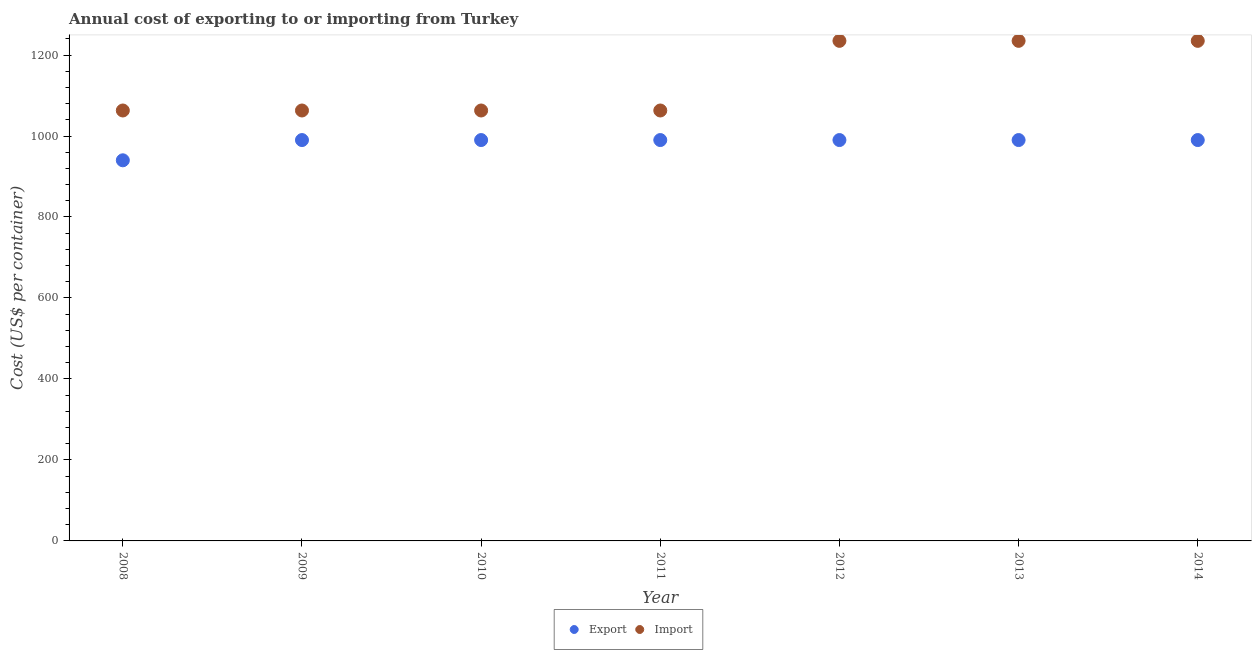How many different coloured dotlines are there?
Give a very brief answer. 2. What is the export cost in 2008?
Offer a terse response. 940. Across all years, what is the maximum export cost?
Provide a succinct answer. 990. Across all years, what is the minimum import cost?
Give a very brief answer. 1063. In which year was the export cost maximum?
Your response must be concise. 2009. In which year was the import cost minimum?
Ensure brevity in your answer.  2008. What is the total import cost in the graph?
Your answer should be compact. 7957. What is the difference between the export cost in 2008 and that in 2014?
Provide a succinct answer. -50. What is the difference between the export cost in 2011 and the import cost in 2012?
Your answer should be compact. -245. What is the average import cost per year?
Your answer should be very brief. 1136.71. In the year 2013, what is the difference between the import cost and export cost?
Provide a short and direct response. 245. What is the ratio of the import cost in 2009 to that in 2014?
Your answer should be very brief. 0.86. Is the import cost in 2013 less than that in 2014?
Your response must be concise. No. Is the difference between the import cost in 2008 and 2009 greater than the difference between the export cost in 2008 and 2009?
Keep it short and to the point. Yes. What is the difference between the highest and the second highest export cost?
Provide a succinct answer. 0. What is the difference between the highest and the lowest import cost?
Make the answer very short. 172. Is the sum of the import cost in 2010 and 2014 greater than the maximum export cost across all years?
Offer a very short reply. Yes. What is the difference between two consecutive major ticks on the Y-axis?
Offer a very short reply. 200. Does the graph contain any zero values?
Make the answer very short. No. How are the legend labels stacked?
Provide a short and direct response. Horizontal. What is the title of the graph?
Keep it short and to the point. Annual cost of exporting to or importing from Turkey. Does "Health Care" appear as one of the legend labels in the graph?
Your answer should be very brief. No. What is the label or title of the Y-axis?
Give a very brief answer. Cost (US$ per container). What is the Cost (US$ per container) in Export in 2008?
Give a very brief answer. 940. What is the Cost (US$ per container) of Import in 2008?
Give a very brief answer. 1063. What is the Cost (US$ per container) of Export in 2009?
Keep it short and to the point. 990. What is the Cost (US$ per container) in Import in 2009?
Offer a very short reply. 1063. What is the Cost (US$ per container) in Export in 2010?
Your response must be concise. 990. What is the Cost (US$ per container) in Import in 2010?
Ensure brevity in your answer.  1063. What is the Cost (US$ per container) of Export in 2011?
Your answer should be compact. 990. What is the Cost (US$ per container) of Import in 2011?
Ensure brevity in your answer.  1063. What is the Cost (US$ per container) of Export in 2012?
Give a very brief answer. 990. What is the Cost (US$ per container) of Import in 2012?
Provide a succinct answer. 1235. What is the Cost (US$ per container) of Export in 2013?
Offer a very short reply. 990. What is the Cost (US$ per container) of Import in 2013?
Offer a very short reply. 1235. What is the Cost (US$ per container) in Export in 2014?
Give a very brief answer. 990. What is the Cost (US$ per container) of Import in 2014?
Give a very brief answer. 1235. Across all years, what is the maximum Cost (US$ per container) in Export?
Your answer should be very brief. 990. Across all years, what is the maximum Cost (US$ per container) of Import?
Your response must be concise. 1235. Across all years, what is the minimum Cost (US$ per container) in Export?
Provide a short and direct response. 940. Across all years, what is the minimum Cost (US$ per container) in Import?
Offer a terse response. 1063. What is the total Cost (US$ per container) of Export in the graph?
Ensure brevity in your answer.  6880. What is the total Cost (US$ per container) of Import in the graph?
Your answer should be very brief. 7957. What is the difference between the Cost (US$ per container) of Export in 2008 and that in 2009?
Keep it short and to the point. -50. What is the difference between the Cost (US$ per container) of Export in 2008 and that in 2011?
Keep it short and to the point. -50. What is the difference between the Cost (US$ per container) in Import in 2008 and that in 2012?
Your response must be concise. -172. What is the difference between the Cost (US$ per container) of Import in 2008 and that in 2013?
Make the answer very short. -172. What is the difference between the Cost (US$ per container) in Export in 2008 and that in 2014?
Provide a short and direct response. -50. What is the difference between the Cost (US$ per container) in Import in 2008 and that in 2014?
Offer a terse response. -172. What is the difference between the Cost (US$ per container) of Import in 2009 and that in 2010?
Provide a short and direct response. 0. What is the difference between the Cost (US$ per container) in Export in 2009 and that in 2011?
Provide a succinct answer. 0. What is the difference between the Cost (US$ per container) in Import in 2009 and that in 2012?
Make the answer very short. -172. What is the difference between the Cost (US$ per container) in Export in 2009 and that in 2013?
Your answer should be very brief. 0. What is the difference between the Cost (US$ per container) of Import in 2009 and that in 2013?
Your answer should be compact. -172. What is the difference between the Cost (US$ per container) in Import in 2009 and that in 2014?
Your response must be concise. -172. What is the difference between the Cost (US$ per container) in Export in 2010 and that in 2012?
Offer a terse response. 0. What is the difference between the Cost (US$ per container) in Import in 2010 and that in 2012?
Provide a succinct answer. -172. What is the difference between the Cost (US$ per container) of Export in 2010 and that in 2013?
Provide a short and direct response. 0. What is the difference between the Cost (US$ per container) of Import in 2010 and that in 2013?
Ensure brevity in your answer.  -172. What is the difference between the Cost (US$ per container) of Import in 2010 and that in 2014?
Keep it short and to the point. -172. What is the difference between the Cost (US$ per container) in Import in 2011 and that in 2012?
Make the answer very short. -172. What is the difference between the Cost (US$ per container) of Import in 2011 and that in 2013?
Keep it short and to the point. -172. What is the difference between the Cost (US$ per container) in Import in 2011 and that in 2014?
Offer a very short reply. -172. What is the difference between the Cost (US$ per container) in Export in 2012 and that in 2014?
Provide a succinct answer. 0. What is the difference between the Cost (US$ per container) in Import in 2012 and that in 2014?
Ensure brevity in your answer.  0. What is the difference between the Cost (US$ per container) in Export in 2013 and that in 2014?
Ensure brevity in your answer.  0. What is the difference between the Cost (US$ per container) in Export in 2008 and the Cost (US$ per container) in Import in 2009?
Ensure brevity in your answer.  -123. What is the difference between the Cost (US$ per container) in Export in 2008 and the Cost (US$ per container) in Import in 2010?
Offer a very short reply. -123. What is the difference between the Cost (US$ per container) of Export in 2008 and the Cost (US$ per container) of Import in 2011?
Provide a short and direct response. -123. What is the difference between the Cost (US$ per container) of Export in 2008 and the Cost (US$ per container) of Import in 2012?
Keep it short and to the point. -295. What is the difference between the Cost (US$ per container) of Export in 2008 and the Cost (US$ per container) of Import in 2013?
Keep it short and to the point. -295. What is the difference between the Cost (US$ per container) of Export in 2008 and the Cost (US$ per container) of Import in 2014?
Your answer should be compact. -295. What is the difference between the Cost (US$ per container) in Export in 2009 and the Cost (US$ per container) in Import in 2010?
Your response must be concise. -73. What is the difference between the Cost (US$ per container) of Export in 2009 and the Cost (US$ per container) of Import in 2011?
Make the answer very short. -73. What is the difference between the Cost (US$ per container) in Export in 2009 and the Cost (US$ per container) in Import in 2012?
Provide a succinct answer. -245. What is the difference between the Cost (US$ per container) in Export in 2009 and the Cost (US$ per container) in Import in 2013?
Make the answer very short. -245. What is the difference between the Cost (US$ per container) in Export in 2009 and the Cost (US$ per container) in Import in 2014?
Your answer should be compact. -245. What is the difference between the Cost (US$ per container) in Export in 2010 and the Cost (US$ per container) in Import in 2011?
Provide a short and direct response. -73. What is the difference between the Cost (US$ per container) of Export in 2010 and the Cost (US$ per container) of Import in 2012?
Your response must be concise. -245. What is the difference between the Cost (US$ per container) of Export in 2010 and the Cost (US$ per container) of Import in 2013?
Make the answer very short. -245. What is the difference between the Cost (US$ per container) in Export in 2010 and the Cost (US$ per container) in Import in 2014?
Make the answer very short. -245. What is the difference between the Cost (US$ per container) of Export in 2011 and the Cost (US$ per container) of Import in 2012?
Ensure brevity in your answer.  -245. What is the difference between the Cost (US$ per container) of Export in 2011 and the Cost (US$ per container) of Import in 2013?
Make the answer very short. -245. What is the difference between the Cost (US$ per container) in Export in 2011 and the Cost (US$ per container) in Import in 2014?
Ensure brevity in your answer.  -245. What is the difference between the Cost (US$ per container) of Export in 2012 and the Cost (US$ per container) of Import in 2013?
Ensure brevity in your answer.  -245. What is the difference between the Cost (US$ per container) in Export in 2012 and the Cost (US$ per container) in Import in 2014?
Provide a succinct answer. -245. What is the difference between the Cost (US$ per container) of Export in 2013 and the Cost (US$ per container) of Import in 2014?
Your answer should be very brief. -245. What is the average Cost (US$ per container) of Export per year?
Offer a terse response. 982.86. What is the average Cost (US$ per container) of Import per year?
Ensure brevity in your answer.  1136.71. In the year 2008, what is the difference between the Cost (US$ per container) in Export and Cost (US$ per container) in Import?
Offer a very short reply. -123. In the year 2009, what is the difference between the Cost (US$ per container) in Export and Cost (US$ per container) in Import?
Your answer should be very brief. -73. In the year 2010, what is the difference between the Cost (US$ per container) in Export and Cost (US$ per container) in Import?
Keep it short and to the point. -73. In the year 2011, what is the difference between the Cost (US$ per container) in Export and Cost (US$ per container) in Import?
Offer a very short reply. -73. In the year 2012, what is the difference between the Cost (US$ per container) in Export and Cost (US$ per container) in Import?
Give a very brief answer. -245. In the year 2013, what is the difference between the Cost (US$ per container) of Export and Cost (US$ per container) of Import?
Give a very brief answer. -245. In the year 2014, what is the difference between the Cost (US$ per container) in Export and Cost (US$ per container) in Import?
Your response must be concise. -245. What is the ratio of the Cost (US$ per container) of Export in 2008 to that in 2009?
Provide a short and direct response. 0.95. What is the ratio of the Cost (US$ per container) in Import in 2008 to that in 2009?
Your answer should be compact. 1. What is the ratio of the Cost (US$ per container) of Export in 2008 to that in 2010?
Your response must be concise. 0.95. What is the ratio of the Cost (US$ per container) in Export in 2008 to that in 2011?
Give a very brief answer. 0.95. What is the ratio of the Cost (US$ per container) of Import in 2008 to that in 2011?
Make the answer very short. 1. What is the ratio of the Cost (US$ per container) in Export in 2008 to that in 2012?
Ensure brevity in your answer.  0.95. What is the ratio of the Cost (US$ per container) in Import in 2008 to that in 2012?
Offer a very short reply. 0.86. What is the ratio of the Cost (US$ per container) in Export in 2008 to that in 2013?
Provide a succinct answer. 0.95. What is the ratio of the Cost (US$ per container) in Import in 2008 to that in 2013?
Make the answer very short. 0.86. What is the ratio of the Cost (US$ per container) of Export in 2008 to that in 2014?
Make the answer very short. 0.95. What is the ratio of the Cost (US$ per container) in Import in 2008 to that in 2014?
Provide a succinct answer. 0.86. What is the ratio of the Cost (US$ per container) in Export in 2009 to that in 2010?
Your answer should be very brief. 1. What is the ratio of the Cost (US$ per container) in Import in 2009 to that in 2010?
Ensure brevity in your answer.  1. What is the ratio of the Cost (US$ per container) of Export in 2009 to that in 2011?
Give a very brief answer. 1. What is the ratio of the Cost (US$ per container) of Import in 2009 to that in 2011?
Provide a short and direct response. 1. What is the ratio of the Cost (US$ per container) in Export in 2009 to that in 2012?
Ensure brevity in your answer.  1. What is the ratio of the Cost (US$ per container) of Import in 2009 to that in 2012?
Offer a terse response. 0.86. What is the ratio of the Cost (US$ per container) in Export in 2009 to that in 2013?
Make the answer very short. 1. What is the ratio of the Cost (US$ per container) of Import in 2009 to that in 2013?
Provide a succinct answer. 0.86. What is the ratio of the Cost (US$ per container) in Export in 2009 to that in 2014?
Provide a short and direct response. 1. What is the ratio of the Cost (US$ per container) in Import in 2009 to that in 2014?
Ensure brevity in your answer.  0.86. What is the ratio of the Cost (US$ per container) of Import in 2010 to that in 2012?
Your answer should be compact. 0.86. What is the ratio of the Cost (US$ per container) in Export in 2010 to that in 2013?
Make the answer very short. 1. What is the ratio of the Cost (US$ per container) in Import in 2010 to that in 2013?
Provide a short and direct response. 0.86. What is the ratio of the Cost (US$ per container) of Import in 2010 to that in 2014?
Give a very brief answer. 0.86. What is the ratio of the Cost (US$ per container) of Import in 2011 to that in 2012?
Your answer should be compact. 0.86. What is the ratio of the Cost (US$ per container) of Export in 2011 to that in 2013?
Give a very brief answer. 1. What is the ratio of the Cost (US$ per container) of Import in 2011 to that in 2013?
Your response must be concise. 0.86. What is the ratio of the Cost (US$ per container) in Export in 2011 to that in 2014?
Keep it short and to the point. 1. What is the ratio of the Cost (US$ per container) of Import in 2011 to that in 2014?
Offer a very short reply. 0.86. What is the ratio of the Cost (US$ per container) of Export in 2012 to that in 2013?
Ensure brevity in your answer.  1. What is the ratio of the Cost (US$ per container) of Import in 2012 to that in 2013?
Keep it short and to the point. 1. What is the ratio of the Cost (US$ per container) of Import in 2013 to that in 2014?
Provide a short and direct response. 1. What is the difference between the highest and the lowest Cost (US$ per container) in Import?
Make the answer very short. 172. 